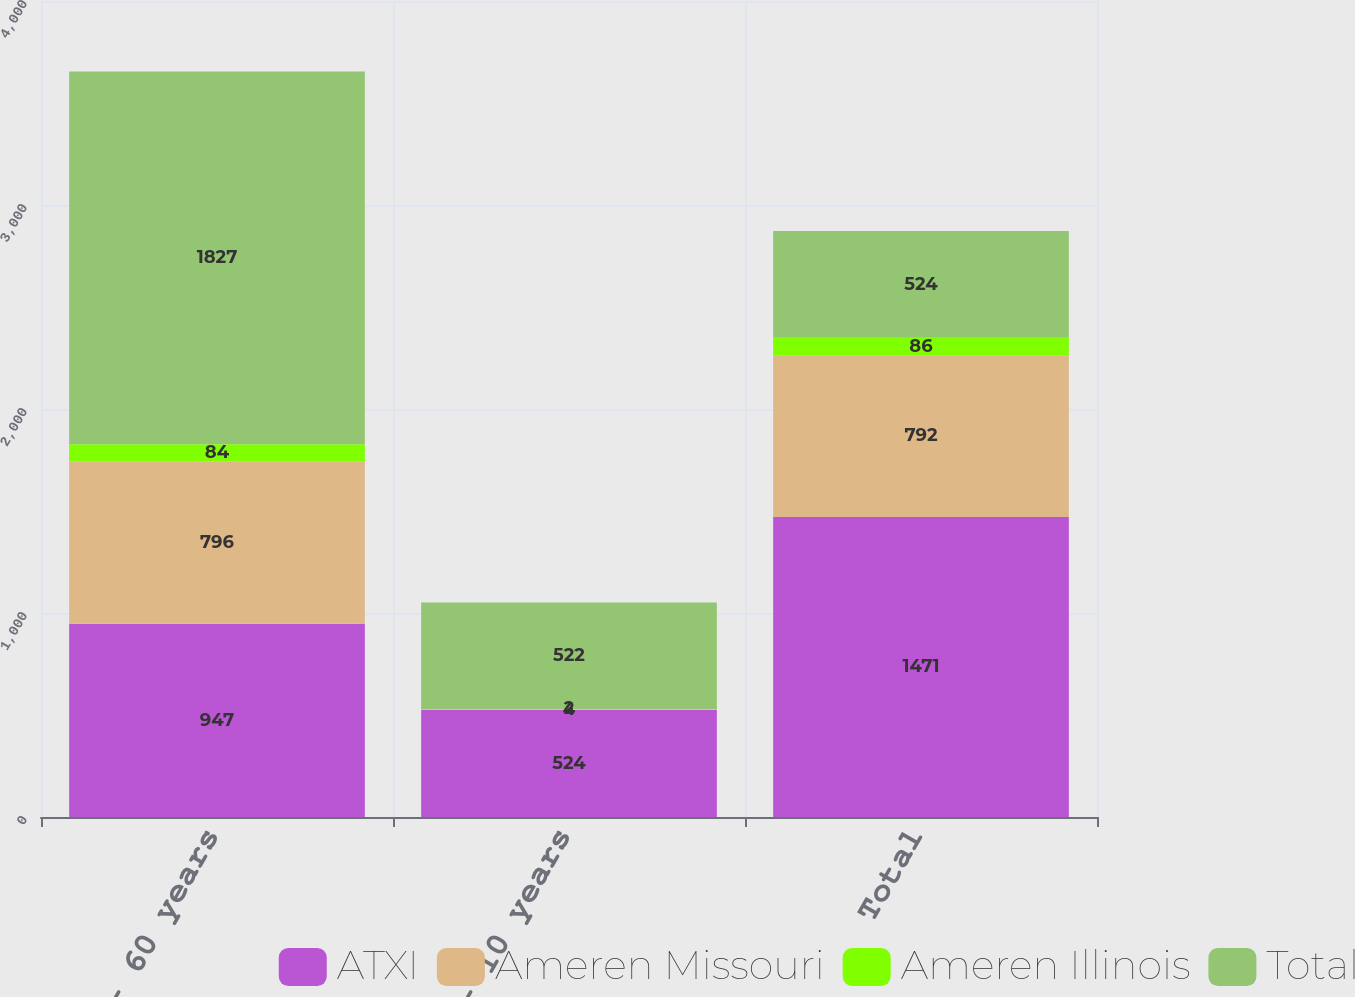Convert chart. <chart><loc_0><loc_0><loc_500><loc_500><stacked_bar_chart><ecel><fcel>30 - 60 years<fcel>7 - 10 years<fcel>Total<nl><fcel>ATXI<fcel>947<fcel>524<fcel>1471<nl><fcel>Ameren Missouri<fcel>796<fcel>4<fcel>792<nl><fcel>Ameren Illinois<fcel>84<fcel>2<fcel>86<nl><fcel>Total<fcel>1827<fcel>522<fcel>524<nl></chart> 